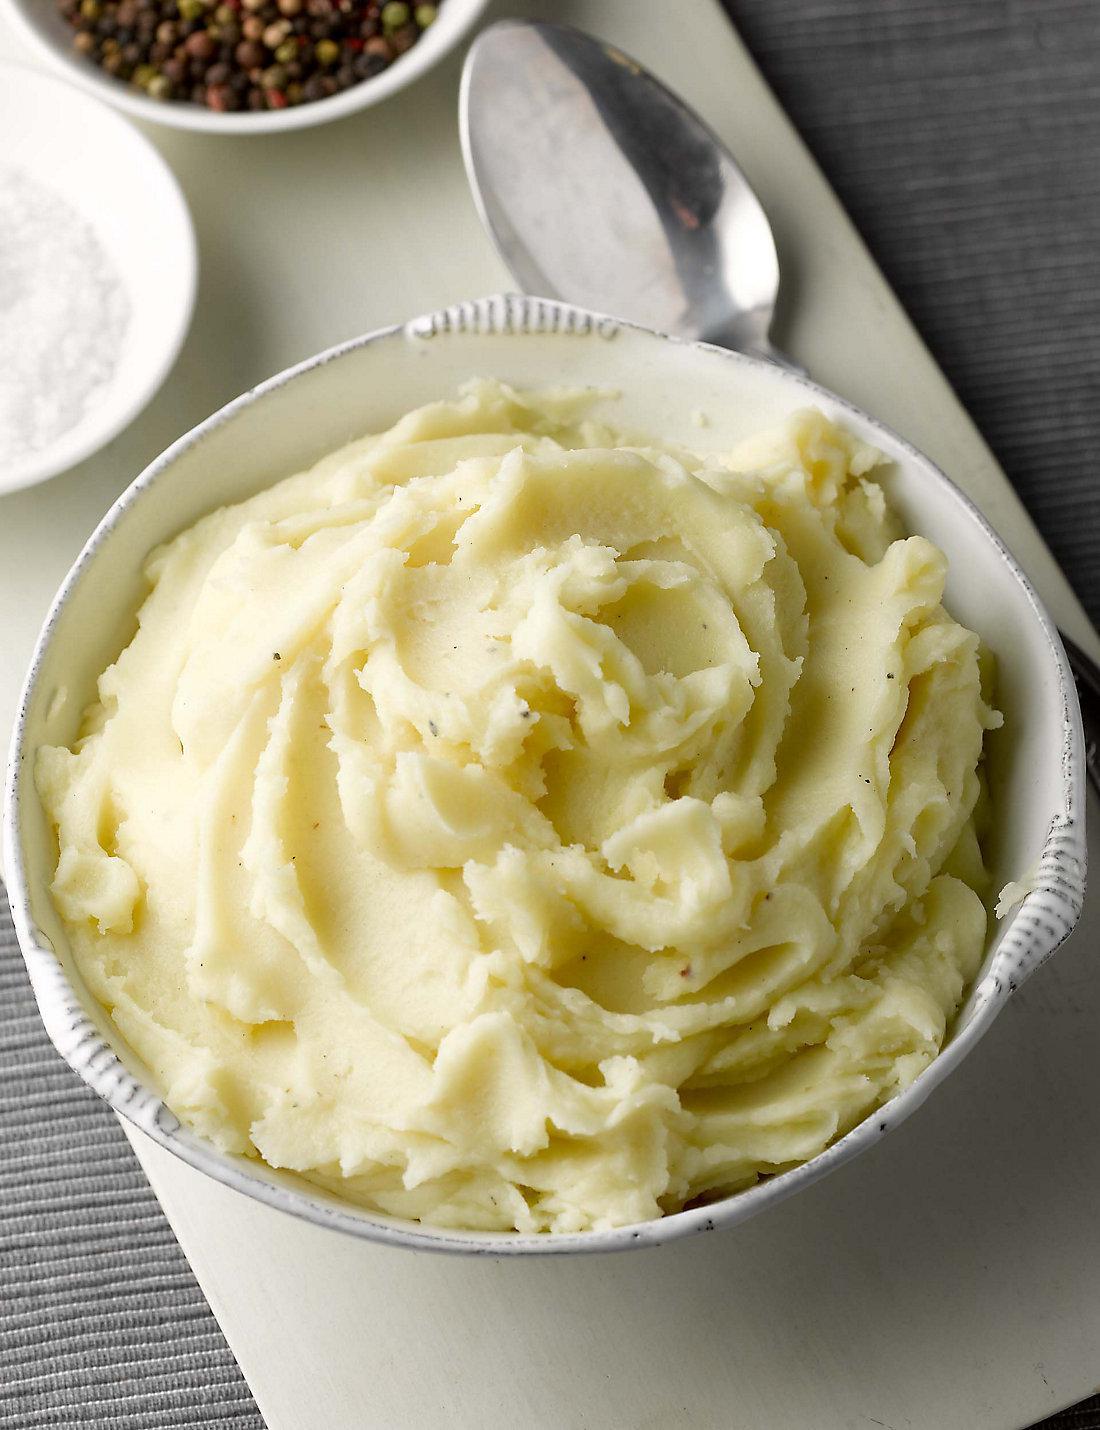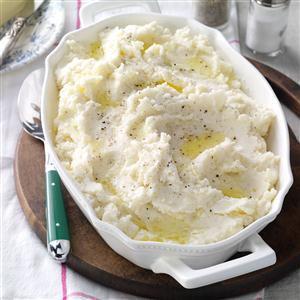The first image is the image on the left, the second image is the image on the right. Examine the images to the left and right. Is the description "One image shows a bowl of mashed potatoes with no spoon near it." accurate? Answer yes or no. No. 